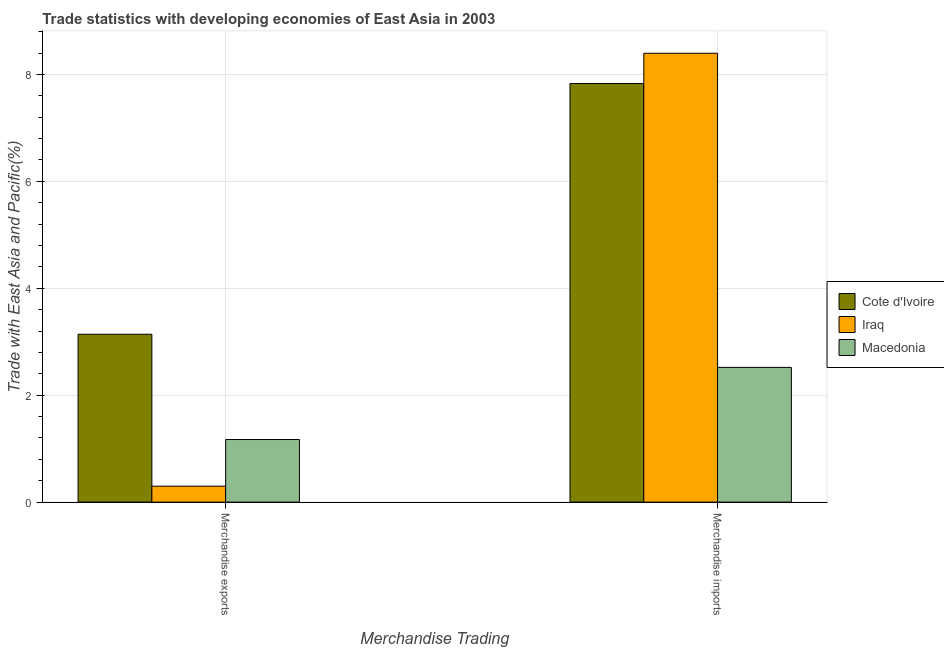How many different coloured bars are there?
Provide a short and direct response. 3. How many groups of bars are there?
Ensure brevity in your answer.  2. Are the number of bars per tick equal to the number of legend labels?
Provide a succinct answer. Yes. How many bars are there on the 2nd tick from the left?
Your answer should be compact. 3. How many bars are there on the 2nd tick from the right?
Offer a very short reply. 3. What is the label of the 2nd group of bars from the left?
Ensure brevity in your answer.  Merchandise imports. What is the merchandise exports in Cote d'Ivoire?
Make the answer very short. 3.14. Across all countries, what is the maximum merchandise exports?
Offer a very short reply. 3.14. Across all countries, what is the minimum merchandise imports?
Provide a short and direct response. 2.52. In which country was the merchandise imports maximum?
Give a very brief answer. Iraq. In which country was the merchandise exports minimum?
Your answer should be compact. Iraq. What is the total merchandise imports in the graph?
Make the answer very short. 18.75. What is the difference between the merchandise imports in Iraq and that in Macedonia?
Your response must be concise. 5.88. What is the difference between the merchandise exports in Iraq and the merchandise imports in Cote d'Ivoire?
Offer a very short reply. -7.53. What is the average merchandise exports per country?
Offer a terse response. 1.54. What is the difference between the merchandise imports and merchandise exports in Macedonia?
Your response must be concise. 1.35. What is the ratio of the merchandise imports in Iraq to that in Cote d'Ivoire?
Offer a very short reply. 1.07. Is the merchandise imports in Iraq less than that in Cote d'Ivoire?
Your response must be concise. No. In how many countries, is the merchandise imports greater than the average merchandise imports taken over all countries?
Offer a very short reply. 2. What does the 1st bar from the left in Merchandise exports represents?
Give a very brief answer. Cote d'Ivoire. What does the 2nd bar from the right in Merchandise exports represents?
Provide a succinct answer. Iraq. Are all the bars in the graph horizontal?
Provide a short and direct response. No. What is the difference between two consecutive major ticks on the Y-axis?
Give a very brief answer. 2. Are the values on the major ticks of Y-axis written in scientific E-notation?
Your answer should be very brief. No. What is the title of the graph?
Keep it short and to the point. Trade statistics with developing economies of East Asia in 2003. What is the label or title of the X-axis?
Your answer should be very brief. Merchandise Trading. What is the label or title of the Y-axis?
Give a very brief answer. Trade with East Asia and Pacific(%). What is the Trade with East Asia and Pacific(%) of Cote d'Ivoire in Merchandise exports?
Keep it short and to the point. 3.14. What is the Trade with East Asia and Pacific(%) of Iraq in Merchandise exports?
Your answer should be compact. 0.3. What is the Trade with East Asia and Pacific(%) of Macedonia in Merchandise exports?
Your answer should be compact. 1.17. What is the Trade with East Asia and Pacific(%) of Cote d'Ivoire in Merchandise imports?
Offer a terse response. 7.83. What is the Trade with East Asia and Pacific(%) of Iraq in Merchandise imports?
Offer a very short reply. 8.4. What is the Trade with East Asia and Pacific(%) of Macedonia in Merchandise imports?
Your answer should be very brief. 2.52. Across all Merchandise Trading, what is the maximum Trade with East Asia and Pacific(%) of Cote d'Ivoire?
Provide a succinct answer. 7.83. Across all Merchandise Trading, what is the maximum Trade with East Asia and Pacific(%) in Iraq?
Provide a succinct answer. 8.4. Across all Merchandise Trading, what is the maximum Trade with East Asia and Pacific(%) of Macedonia?
Offer a very short reply. 2.52. Across all Merchandise Trading, what is the minimum Trade with East Asia and Pacific(%) in Cote d'Ivoire?
Offer a terse response. 3.14. Across all Merchandise Trading, what is the minimum Trade with East Asia and Pacific(%) in Iraq?
Offer a very short reply. 0.3. Across all Merchandise Trading, what is the minimum Trade with East Asia and Pacific(%) of Macedonia?
Give a very brief answer. 1.17. What is the total Trade with East Asia and Pacific(%) of Cote d'Ivoire in the graph?
Offer a very short reply. 10.97. What is the total Trade with East Asia and Pacific(%) of Iraq in the graph?
Give a very brief answer. 8.69. What is the total Trade with East Asia and Pacific(%) in Macedonia in the graph?
Offer a terse response. 3.69. What is the difference between the Trade with East Asia and Pacific(%) in Cote d'Ivoire in Merchandise exports and that in Merchandise imports?
Offer a very short reply. -4.69. What is the difference between the Trade with East Asia and Pacific(%) in Iraq in Merchandise exports and that in Merchandise imports?
Provide a succinct answer. -8.1. What is the difference between the Trade with East Asia and Pacific(%) in Macedonia in Merchandise exports and that in Merchandise imports?
Your response must be concise. -1.35. What is the difference between the Trade with East Asia and Pacific(%) of Cote d'Ivoire in Merchandise exports and the Trade with East Asia and Pacific(%) of Iraq in Merchandise imports?
Your answer should be very brief. -5.26. What is the difference between the Trade with East Asia and Pacific(%) in Cote d'Ivoire in Merchandise exports and the Trade with East Asia and Pacific(%) in Macedonia in Merchandise imports?
Your response must be concise. 0.62. What is the difference between the Trade with East Asia and Pacific(%) of Iraq in Merchandise exports and the Trade with East Asia and Pacific(%) of Macedonia in Merchandise imports?
Give a very brief answer. -2.22. What is the average Trade with East Asia and Pacific(%) of Cote d'Ivoire per Merchandise Trading?
Your answer should be compact. 5.49. What is the average Trade with East Asia and Pacific(%) of Iraq per Merchandise Trading?
Your answer should be very brief. 4.35. What is the average Trade with East Asia and Pacific(%) in Macedonia per Merchandise Trading?
Your answer should be compact. 1.85. What is the difference between the Trade with East Asia and Pacific(%) in Cote d'Ivoire and Trade with East Asia and Pacific(%) in Iraq in Merchandise exports?
Your answer should be compact. 2.84. What is the difference between the Trade with East Asia and Pacific(%) of Cote d'Ivoire and Trade with East Asia and Pacific(%) of Macedonia in Merchandise exports?
Give a very brief answer. 1.97. What is the difference between the Trade with East Asia and Pacific(%) in Iraq and Trade with East Asia and Pacific(%) in Macedonia in Merchandise exports?
Provide a short and direct response. -0.87. What is the difference between the Trade with East Asia and Pacific(%) of Cote d'Ivoire and Trade with East Asia and Pacific(%) of Iraq in Merchandise imports?
Offer a terse response. -0.57. What is the difference between the Trade with East Asia and Pacific(%) of Cote d'Ivoire and Trade with East Asia and Pacific(%) of Macedonia in Merchandise imports?
Give a very brief answer. 5.31. What is the difference between the Trade with East Asia and Pacific(%) in Iraq and Trade with East Asia and Pacific(%) in Macedonia in Merchandise imports?
Ensure brevity in your answer.  5.88. What is the ratio of the Trade with East Asia and Pacific(%) in Cote d'Ivoire in Merchandise exports to that in Merchandise imports?
Make the answer very short. 0.4. What is the ratio of the Trade with East Asia and Pacific(%) in Iraq in Merchandise exports to that in Merchandise imports?
Provide a short and direct response. 0.04. What is the ratio of the Trade with East Asia and Pacific(%) of Macedonia in Merchandise exports to that in Merchandise imports?
Your answer should be compact. 0.46. What is the difference between the highest and the second highest Trade with East Asia and Pacific(%) of Cote d'Ivoire?
Keep it short and to the point. 4.69. What is the difference between the highest and the second highest Trade with East Asia and Pacific(%) of Iraq?
Your answer should be very brief. 8.1. What is the difference between the highest and the second highest Trade with East Asia and Pacific(%) of Macedonia?
Your answer should be compact. 1.35. What is the difference between the highest and the lowest Trade with East Asia and Pacific(%) of Cote d'Ivoire?
Your answer should be compact. 4.69. What is the difference between the highest and the lowest Trade with East Asia and Pacific(%) of Iraq?
Your answer should be compact. 8.1. What is the difference between the highest and the lowest Trade with East Asia and Pacific(%) in Macedonia?
Give a very brief answer. 1.35. 